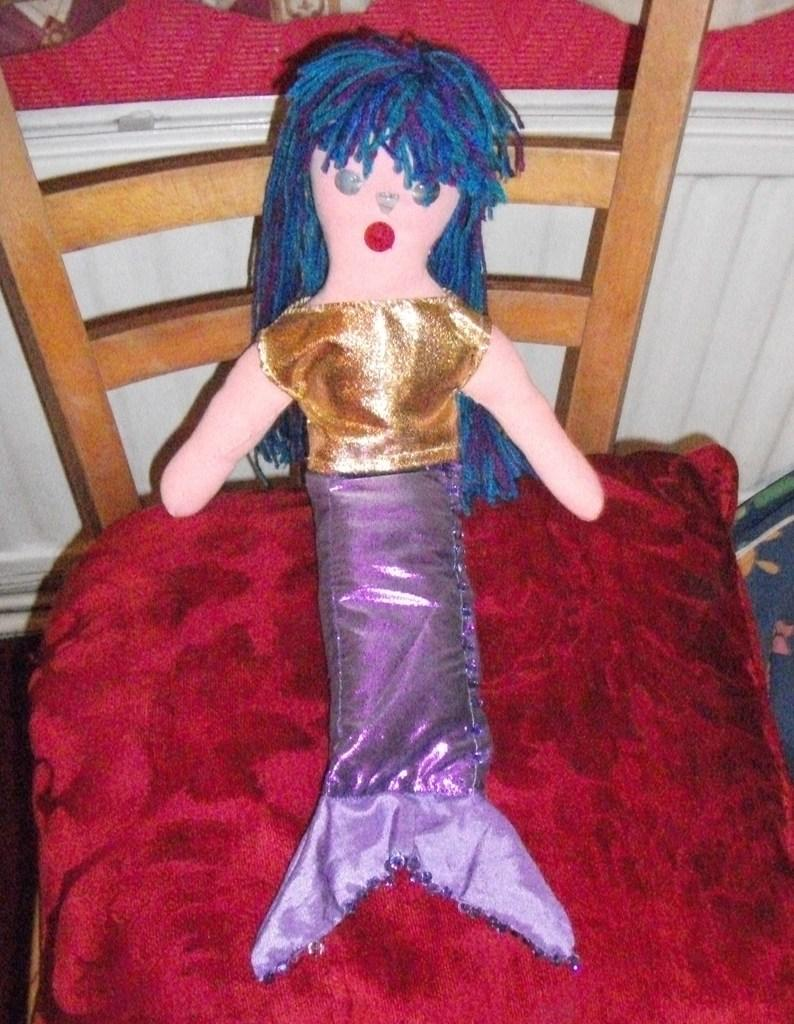What type of toy can be seen in the image? There is a toy in the image, and it is a mermaid. What is the mermaid wearing in the image? The mermaid is wearing a dress in the image. Where is the toy placed in the image? The toy is placed on a chair in the image. How many cakes does the mother bring to the toy in the image? There is no mother or cakes present in the image; it only features a toy mermaid on a chair. 